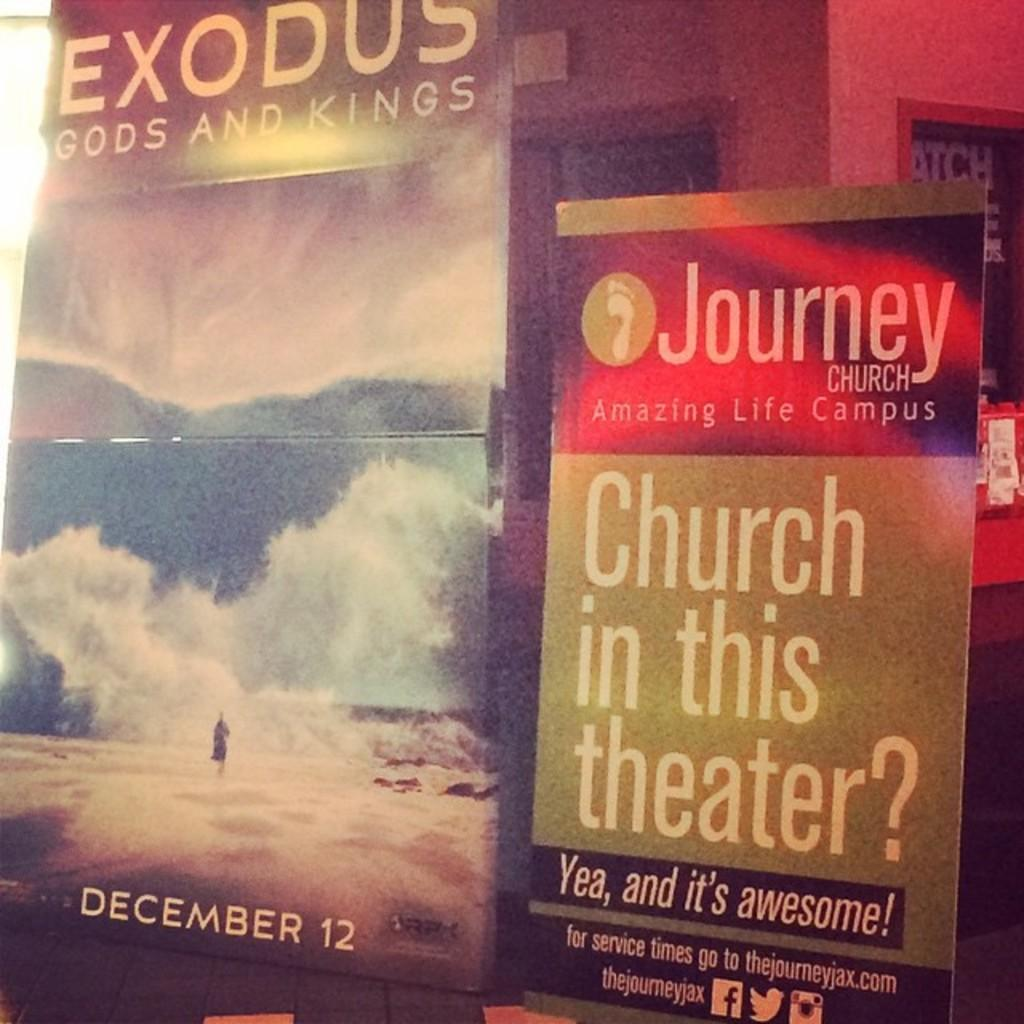<image>
Provide a brief description of the given image. An advertisement for exodus gods and kings on December 12th. 